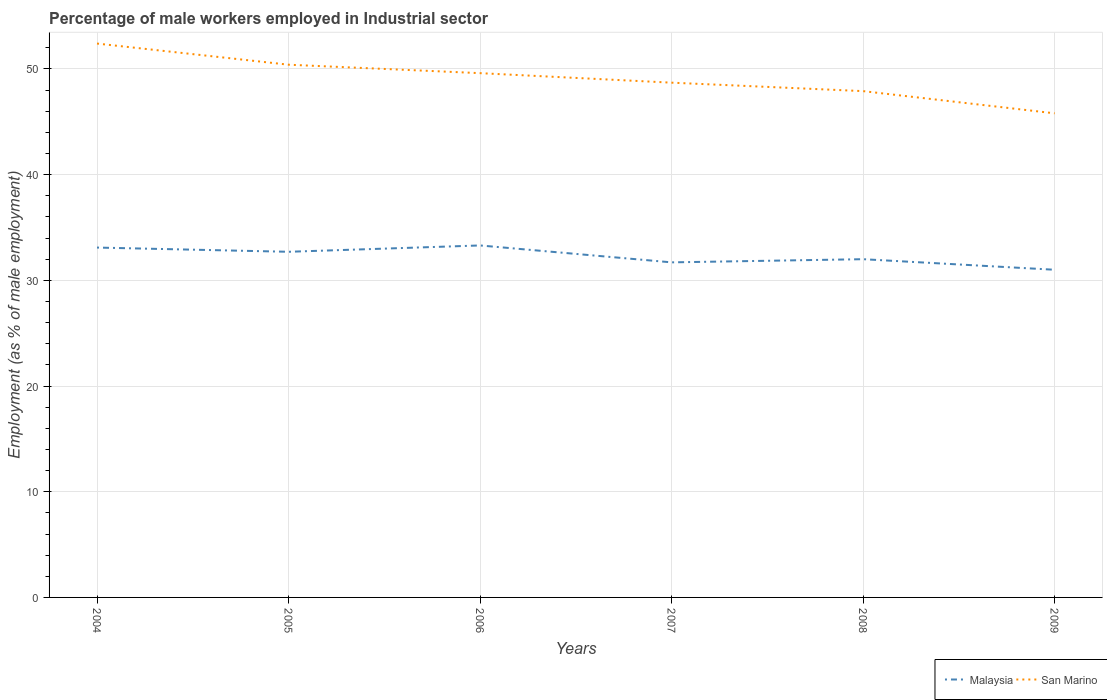How many different coloured lines are there?
Make the answer very short. 2. Does the line corresponding to Malaysia intersect with the line corresponding to San Marino?
Your answer should be compact. No. Is the number of lines equal to the number of legend labels?
Provide a short and direct response. Yes. Across all years, what is the maximum percentage of male workers employed in Industrial sector in Malaysia?
Your answer should be very brief. 31. What is the total percentage of male workers employed in Industrial sector in San Marino in the graph?
Provide a succinct answer. 0.8. What is the difference between the highest and the second highest percentage of male workers employed in Industrial sector in Malaysia?
Give a very brief answer. 2.3. What is the difference between the highest and the lowest percentage of male workers employed in Industrial sector in San Marino?
Your answer should be compact. 3. How many lines are there?
Ensure brevity in your answer.  2. Does the graph contain any zero values?
Offer a very short reply. No. Does the graph contain grids?
Your answer should be compact. Yes. Where does the legend appear in the graph?
Give a very brief answer. Bottom right. How are the legend labels stacked?
Give a very brief answer. Horizontal. What is the title of the graph?
Offer a very short reply. Percentage of male workers employed in Industrial sector. Does "Andorra" appear as one of the legend labels in the graph?
Offer a very short reply. No. What is the label or title of the X-axis?
Ensure brevity in your answer.  Years. What is the label or title of the Y-axis?
Give a very brief answer. Employment (as % of male employment). What is the Employment (as % of male employment) of Malaysia in 2004?
Keep it short and to the point. 33.1. What is the Employment (as % of male employment) in San Marino in 2004?
Give a very brief answer. 52.4. What is the Employment (as % of male employment) in Malaysia in 2005?
Keep it short and to the point. 32.7. What is the Employment (as % of male employment) in San Marino in 2005?
Ensure brevity in your answer.  50.4. What is the Employment (as % of male employment) of Malaysia in 2006?
Give a very brief answer. 33.3. What is the Employment (as % of male employment) in San Marino in 2006?
Provide a short and direct response. 49.6. What is the Employment (as % of male employment) of Malaysia in 2007?
Provide a succinct answer. 31.7. What is the Employment (as % of male employment) in San Marino in 2007?
Your answer should be compact. 48.7. What is the Employment (as % of male employment) of Malaysia in 2008?
Give a very brief answer. 32. What is the Employment (as % of male employment) of San Marino in 2008?
Your response must be concise. 47.9. What is the Employment (as % of male employment) in Malaysia in 2009?
Your answer should be compact. 31. What is the Employment (as % of male employment) of San Marino in 2009?
Provide a succinct answer. 45.8. Across all years, what is the maximum Employment (as % of male employment) of Malaysia?
Your answer should be very brief. 33.3. Across all years, what is the maximum Employment (as % of male employment) of San Marino?
Provide a succinct answer. 52.4. Across all years, what is the minimum Employment (as % of male employment) of Malaysia?
Offer a terse response. 31. Across all years, what is the minimum Employment (as % of male employment) in San Marino?
Provide a short and direct response. 45.8. What is the total Employment (as % of male employment) of Malaysia in the graph?
Offer a terse response. 193.8. What is the total Employment (as % of male employment) of San Marino in the graph?
Provide a succinct answer. 294.8. What is the difference between the Employment (as % of male employment) in San Marino in 2004 and that in 2005?
Provide a succinct answer. 2. What is the difference between the Employment (as % of male employment) in Malaysia in 2004 and that in 2006?
Ensure brevity in your answer.  -0.2. What is the difference between the Employment (as % of male employment) of Malaysia in 2004 and that in 2007?
Offer a very short reply. 1.4. What is the difference between the Employment (as % of male employment) of Malaysia in 2004 and that in 2008?
Your response must be concise. 1.1. What is the difference between the Employment (as % of male employment) of San Marino in 2004 and that in 2008?
Keep it short and to the point. 4.5. What is the difference between the Employment (as % of male employment) of Malaysia in 2005 and that in 2006?
Offer a terse response. -0.6. What is the difference between the Employment (as % of male employment) of San Marino in 2005 and that in 2007?
Your response must be concise. 1.7. What is the difference between the Employment (as % of male employment) in San Marino in 2005 and that in 2008?
Your answer should be compact. 2.5. What is the difference between the Employment (as % of male employment) in Malaysia in 2005 and that in 2009?
Give a very brief answer. 1.7. What is the difference between the Employment (as % of male employment) in Malaysia in 2006 and that in 2007?
Give a very brief answer. 1.6. What is the difference between the Employment (as % of male employment) of San Marino in 2006 and that in 2007?
Provide a short and direct response. 0.9. What is the difference between the Employment (as % of male employment) in Malaysia in 2006 and that in 2009?
Your answer should be compact. 2.3. What is the difference between the Employment (as % of male employment) in San Marino in 2006 and that in 2009?
Your response must be concise. 3.8. What is the difference between the Employment (as % of male employment) in Malaysia in 2007 and that in 2008?
Keep it short and to the point. -0.3. What is the difference between the Employment (as % of male employment) in San Marino in 2007 and that in 2008?
Make the answer very short. 0.8. What is the difference between the Employment (as % of male employment) in Malaysia in 2008 and that in 2009?
Your answer should be very brief. 1. What is the difference between the Employment (as % of male employment) in Malaysia in 2004 and the Employment (as % of male employment) in San Marino in 2005?
Provide a short and direct response. -17.3. What is the difference between the Employment (as % of male employment) in Malaysia in 2004 and the Employment (as % of male employment) in San Marino in 2006?
Your response must be concise. -16.5. What is the difference between the Employment (as % of male employment) in Malaysia in 2004 and the Employment (as % of male employment) in San Marino in 2007?
Offer a very short reply. -15.6. What is the difference between the Employment (as % of male employment) of Malaysia in 2004 and the Employment (as % of male employment) of San Marino in 2008?
Your answer should be compact. -14.8. What is the difference between the Employment (as % of male employment) in Malaysia in 2005 and the Employment (as % of male employment) in San Marino in 2006?
Ensure brevity in your answer.  -16.9. What is the difference between the Employment (as % of male employment) of Malaysia in 2005 and the Employment (as % of male employment) of San Marino in 2007?
Offer a terse response. -16. What is the difference between the Employment (as % of male employment) in Malaysia in 2005 and the Employment (as % of male employment) in San Marino in 2008?
Your response must be concise. -15.2. What is the difference between the Employment (as % of male employment) in Malaysia in 2006 and the Employment (as % of male employment) in San Marino in 2007?
Provide a succinct answer. -15.4. What is the difference between the Employment (as % of male employment) in Malaysia in 2006 and the Employment (as % of male employment) in San Marino in 2008?
Give a very brief answer. -14.6. What is the difference between the Employment (as % of male employment) in Malaysia in 2007 and the Employment (as % of male employment) in San Marino in 2008?
Offer a terse response. -16.2. What is the difference between the Employment (as % of male employment) in Malaysia in 2007 and the Employment (as % of male employment) in San Marino in 2009?
Offer a very short reply. -14.1. What is the average Employment (as % of male employment) in Malaysia per year?
Provide a short and direct response. 32.3. What is the average Employment (as % of male employment) of San Marino per year?
Your answer should be very brief. 49.13. In the year 2004, what is the difference between the Employment (as % of male employment) of Malaysia and Employment (as % of male employment) of San Marino?
Your answer should be compact. -19.3. In the year 2005, what is the difference between the Employment (as % of male employment) in Malaysia and Employment (as % of male employment) in San Marino?
Your response must be concise. -17.7. In the year 2006, what is the difference between the Employment (as % of male employment) in Malaysia and Employment (as % of male employment) in San Marino?
Give a very brief answer. -16.3. In the year 2007, what is the difference between the Employment (as % of male employment) in Malaysia and Employment (as % of male employment) in San Marino?
Your answer should be compact. -17. In the year 2008, what is the difference between the Employment (as % of male employment) of Malaysia and Employment (as % of male employment) of San Marino?
Provide a succinct answer. -15.9. In the year 2009, what is the difference between the Employment (as % of male employment) of Malaysia and Employment (as % of male employment) of San Marino?
Provide a short and direct response. -14.8. What is the ratio of the Employment (as % of male employment) in Malaysia in 2004 to that in 2005?
Provide a short and direct response. 1.01. What is the ratio of the Employment (as % of male employment) in San Marino in 2004 to that in 2005?
Offer a terse response. 1.04. What is the ratio of the Employment (as % of male employment) in San Marino in 2004 to that in 2006?
Ensure brevity in your answer.  1.06. What is the ratio of the Employment (as % of male employment) of Malaysia in 2004 to that in 2007?
Keep it short and to the point. 1.04. What is the ratio of the Employment (as % of male employment) of San Marino in 2004 to that in 2007?
Offer a very short reply. 1.08. What is the ratio of the Employment (as % of male employment) in Malaysia in 2004 to that in 2008?
Provide a short and direct response. 1.03. What is the ratio of the Employment (as % of male employment) in San Marino in 2004 to that in 2008?
Make the answer very short. 1.09. What is the ratio of the Employment (as % of male employment) of Malaysia in 2004 to that in 2009?
Ensure brevity in your answer.  1.07. What is the ratio of the Employment (as % of male employment) of San Marino in 2004 to that in 2009?
Ensure brevity in your answer.  1.14. What is the ratio of the Employment (as % of male employment) in Malaysia in 2005 to that in 2006?
Give a very brief answer. 0.98. What is the ratio of the Employment (as % of male employment) in San Marino in 2005 to that in 2006?
Provide a succinct answer. 1.02. What is the ratio of the Employment (as % of male employment) in Malaysia in 2005 to that in 2007?
Offer a very short reply. 1.03. What is the ratio of the Employment (as % of male employment) in San Marino in 2005 to that in 2007?
Your answer should be compact. 1.03. What is the ratio of the Employment (as % of male employment) of Malaysia in 2005 to that in 2008?
Your response must be concise. 1.02. What is the ratio of the Employment (as % of male employment) in San Marino in 2005 to that in 2008?
Your answer should be very brief. 1.05. What is the ratio of the Employment (as % of male employment) in Malaysia in 2005 to that in 2009?
Ensure brevity in your answer.  1.05. What is the ratio of the Employment (as % of male employment) of San Marino in 2005 to that in 2009?
Make the answer very short. 1.1. What is the ratio of the Employment (as % of male employment) in Malaysia in 2006 to that in 2007?
Your response must be concise. 1.05. What is the ratio of the Employment (as % of male employment) of San Marino in 2006 to that in 2007?
Offer a terse response. 1.02. What is the ratio of the Employment (as % of male employment) of Malaysia in 2006 to that in 2008?
Keep it short and to the point. 1.04. What is the ratio of the Employment (as % of male employment) in San Marino in 2006 to that in 2008?
Keep it short and to the point. 1.04. What is the ratio of the Employment (as % of male employment) of Malaysia in 2006 to that in 2009?
Offer a very short reply. 1.07. What is the ratio of the Employment (as % of male employment) of San Marino in 2006 to that in 2009?
Provide a short and direct response. 1.08. What is the ratio of the Employment (as % of male employment) of Malaysia in 2007 to that in 2008?
Your answer should be compact. 0.99. What is the ratio of the Employment (as % of male employment) in San Marino in 2007 to that in 2008?
Provide a succinct answer. 1.02. What is the ratio of the Employment (as % of male employment) of Malaysia in 2007 to that in 2009?
Your response must be concise. 1.02. What is the ratio of the Employment (as % of male employment) of San Marino in 2007 to that in 2009?
Give a very brief answer. 1.06. What is the ratio of the Employment (as % of male employment) of Malaysia in 2008 to that in 2009?
Keep it short and to the point. 1.03. What is the ratio of the Employment (as % of male employment) in San Marino in 2008 to that in 2009?
Your answer should be very brief. 1.05. What is the difference between the highest and the second highest Employment (as % of male employment) of San Marino?
Keep it short and to the point. 2. What is the difference between the highest and the lowest Employment (as % of male employment) of San Marino?
Make the answer very short. 6.6. 